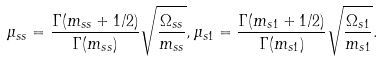Convert formula to latex. <formula><loc_0><loc_0><loc_500><loc_500>\mu _ { s s } = \frac { \Gamma ( m _ { s s } + 1 / 2 ) } { \Gamma ( m _ { s s } ) } \sqrt { \frac { \Omega _ { s s } } { m _ { s s } } } , \mu _ { s 1 } = \frac { \Gamma ( m _ { s 1 } + 1 / 2 ) } { \Gamma ( m _ { s 1 } ) } \sqrt { \frac { \Omega _ { s 1 } } { m _ { s 1 } } } .</formula> 